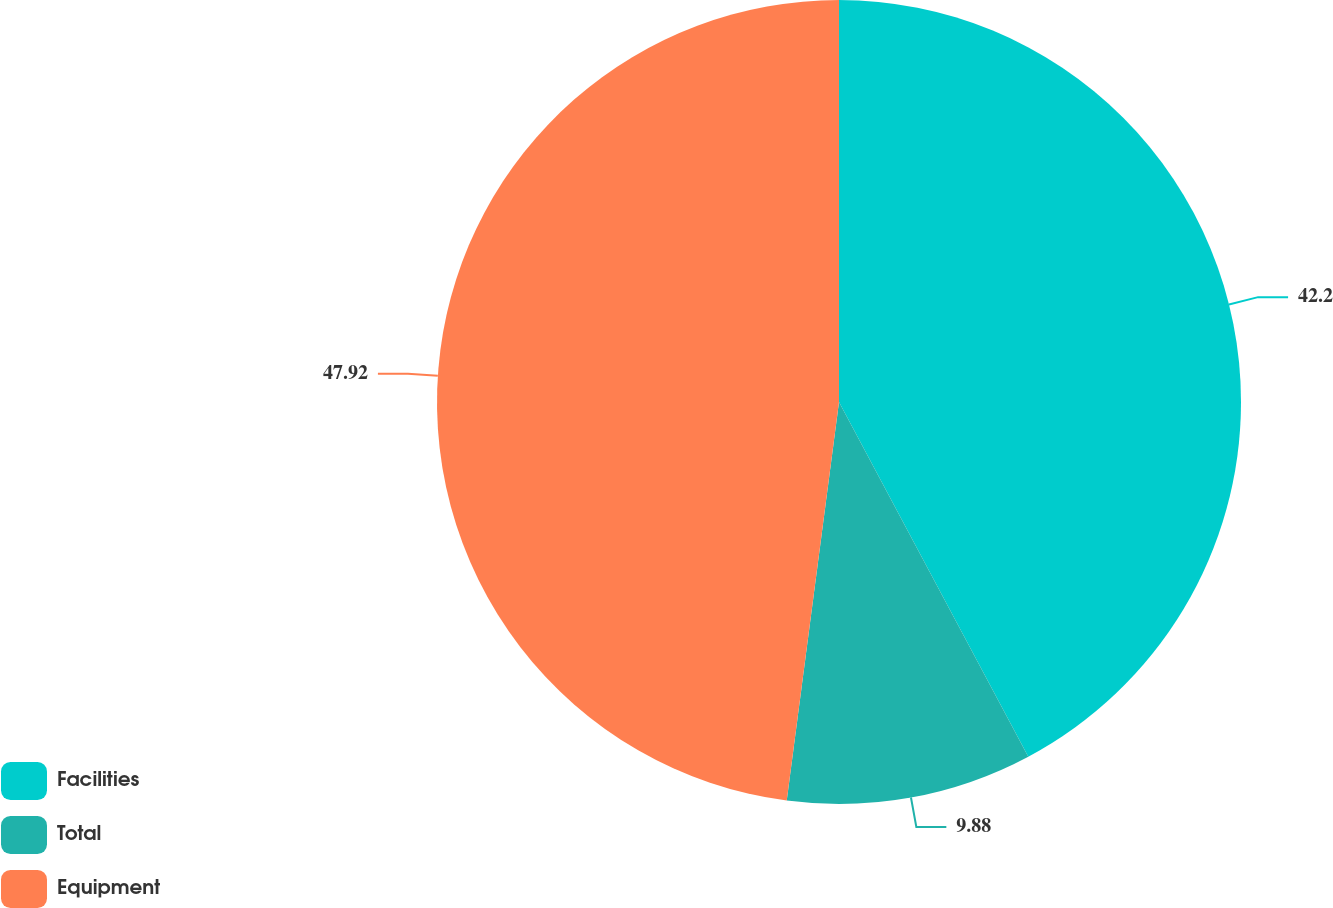Convert chart to OTSL. <chart><loc_0><loc_0><loc_500><loc_500><pie_chart><fcel>Facilities<fcel>Total<fcel>Equipment<nl><fcel>42.2%<fcel>9.88%<fcel>47.93%<nl></chart> 